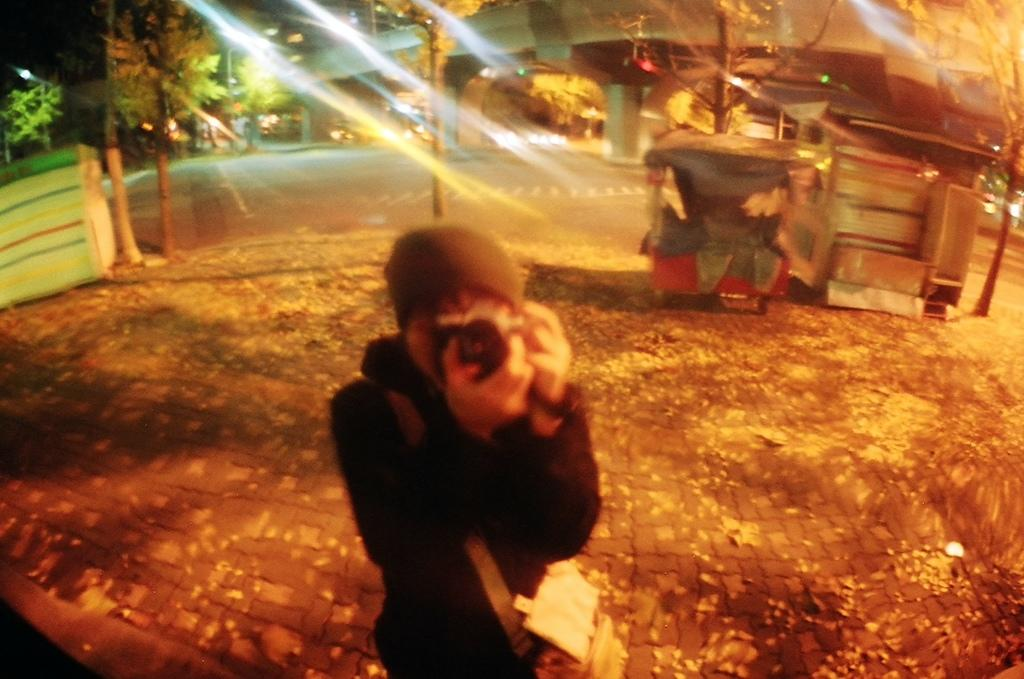What is the person in the image doing? The person is standing on the path of a road. What else can be seen on the path in the image? There are objects placed on the path. What can be seen in the distance in the image? There are buildings and trees in the background of the image. What type of wool is being used for punishment in the image? There is no wool or punishment present in the image. 